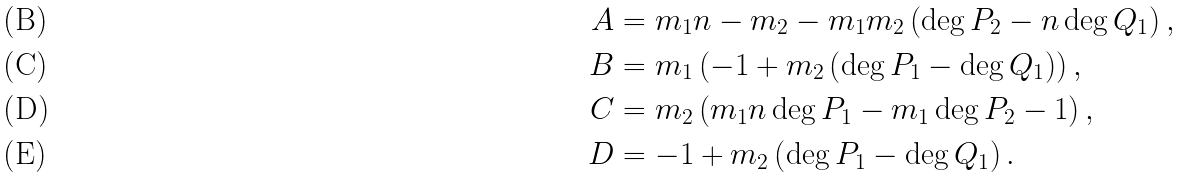<formula> <loc_0><loc_0><loc_500><loc_500>A & = m _ { 1 } n - m _ { 2 } - m _ { 1 } m _ { 2 } \left ( \deg P _ { 2 } - n \deg Q _ { 1 } \right ) , \\ B & = m _ { 1 } \left ( - 1 + m _ { 2 } \left ( \deg P _ { 1 } - \deg Q _ { 1 } \right ) \right ) , \\ C & = m _ { 2 } \left ( m _ { 1 } n \deg P _ { 1 } - m _ { 1 } \deg P _ { 2 } - 1 \right ) , \\ D & = - 1 + m _ { 2 } \left ( \deg P _ { 1 } - \deg Q _ { 1 } \right ) .</formula> 